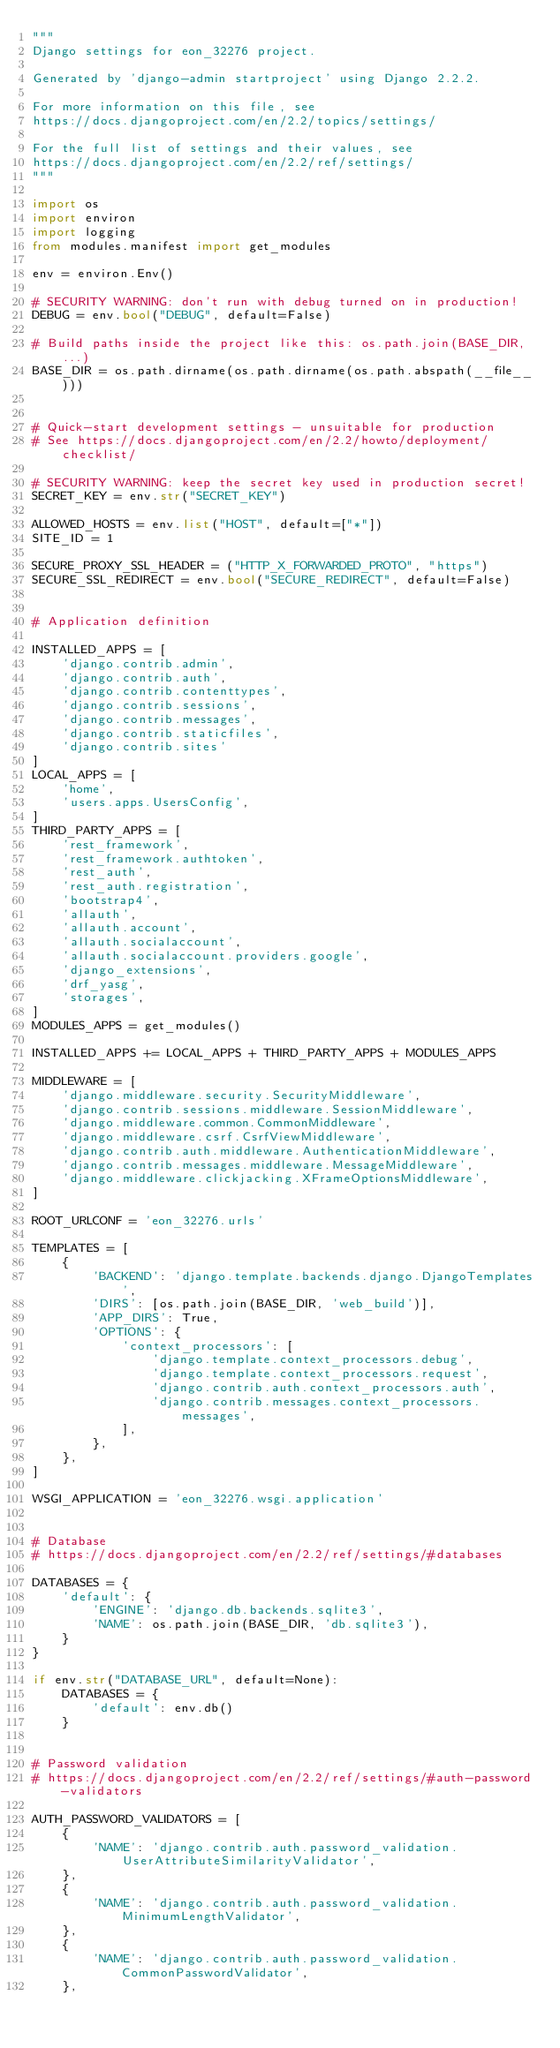<code> <loc_0><loc_0><loc_500><loc_500><_Python_>"""
Django settings for eon_32276 project.

Generated by 'django-admin startproject' using Django 2.2.2.

For more information on this file, see
https://docs.djangoproject.com/en/2.2/topics/settings/

For the full list of settings and their values, see
https://docs.djangoproject.com/en/2.2/ref/settings/
"""

import os
import environ
import logging
from modules.manifest import get_modules

env = environ.Env()

# SECURITY WARNING: don't run with debug turned on in production!
DEBUG = env.bool("DEBUG", default=False)

# Build paths inside the project like this: os.path.join(BASE_DIR, ...)
BASE_DIR = os.path.dirname(os.path.dirname(os.path.abspath(__file__)))


# Quick-start development settings - unsuitable for production
# See https://docs.djangoproject.com/en/2.2/howto/deployment/checklist/

# SECURITY WARNING: keep the secret key used in production secret!
SECRET_KEY = env.str("SECRET_KEY")

ALLOWED_HOSTS = env.list("HOST", default=["*"])
SITE_ID = 1

SECURE_PROXY_SSL_HEADER = ("HTTP_X_FORWARDED_PROTO", "https")
SECURE_SSL_REDIRECT = env.bool("SECURE_REDIRECT", default=False)


# Application definition

INSTALLED_APPS = [
    'django.contrib.admin',
    'django.contrib.auth',
    'django.contrib.contenttypes',
    'django.contrib.sessions',
    'django.contrib.messages',
    'django.contrib.staticfiles',
    'django.contrib.sites'
]
LOCAL_APPS = [
    'home',
    'users.apps.UsersConfig',
]
THIRD_PARTY_APPS = [
    'rest_framework',
    'rest_framework.authtoken',
    'rest_auth',
    'rest_auth.registration',
    'bootstrap4',
    'allauth',
    'allauth.account',
    'allauth.socialaccount',
    'allauth.socialaccount.providers.google',
    'django_extensions',
    'drf_yasg',
    'storages',
]
MODULES_APPS = get_modules()

INSTALLED_APPS += LOCAL_APPS + THIRD_PARTY_APPS + MODULES_APPS

MIDDLEWARE = [
    'django.middleware.security.SecurityMiddleware',
    'django.contrib.sessions.middleware.SessionMiddleware',
    'django.middleware.common.CommonMiddleware',
    'django.middleware.csrf.CsrfViewMiddleware',
    'django.contrib.auth.middleware.AuthenticationMiddleware',
    'django.contrib.messages.middleware.MessageMiddleware',
    'django.middleware.clickjacking.XFrameOptionsMiddleware',
]

ROOT_URLCONF = 'eon_32276.urls'

TEMPLATES = [
    {
        'BACKEND': 'django.template.backends.django.DjangoTemplates',
        'DIRS': [os.path.join(BASE_DIR, 'web_build')],
        'APP_DIRS': True,
        'OPTIONS': {
            'context_processors': [
                'django.template.context_processors.debug',
                'django.template.context_processors.request',
                'django.contrib.auth.context_processors.auth',
                'django.contrib.messages.context_processors.messages',
            ],
        },
    },
]

WSGI_APPLICATION = 'eon_32276.wsgi.application'


# Database
# https://docs.djangoproject.com/en/2.2/ref/settings/#databases

DATABASES = {
    'default': {
        'ENGINE': 'django.db.backends.sqlite3',
        'NAME': os.path.join(BASE_DIR, 'db.sqlite3'),
    }
}

if env.str("DATABASE_URL", default=None):
    DATABASES = {
        'default': env.db()
    }


# Password validation
# https://docs.djangoproject.com/en/2.2/ref/settings/#auth-password-validators

AUTH_PASSWORD_VALIDATORS = [
    {
        'NAME': 'django.contrib.auth.password_validation.UserAttributeSimilarityValidator',
    },
    {
        'NAME': 'django.contrib.auth.password_validation.MinimumLengthValidator',
    },
    {
        'NAME': 'django.contrib.auth.password_validation.CommonPasswordValidator',
    },</code> 